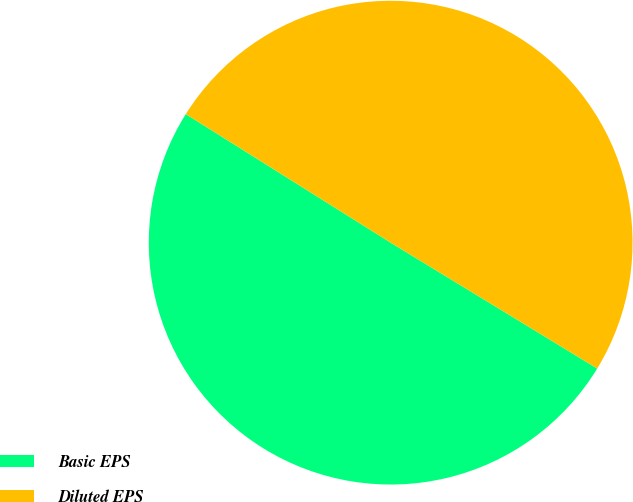Convert chart. <chart><loc_0><loc_0><loc_500><loc_500><pie_chart><fcel>Basic EPS<fcel>Diluted EPS<nl><fcel>50.21%<fcel>49.79%<nl></chart> 